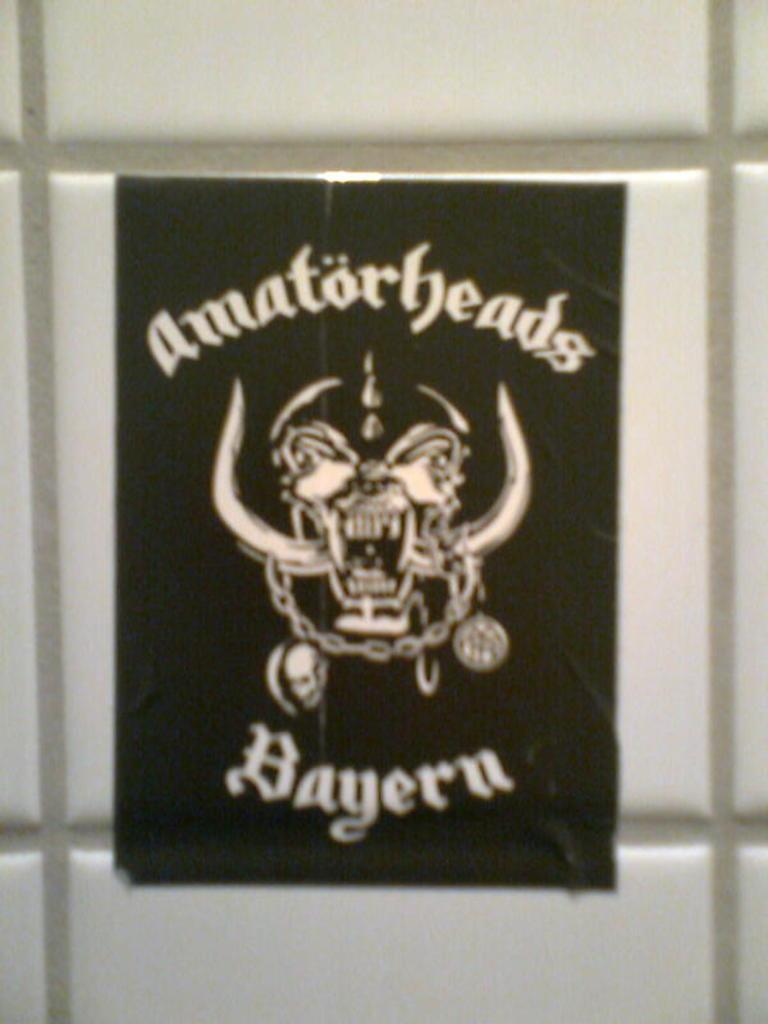What is featured on the poster in the image? The poster has "amator heads" written on it. Where is the poster located in the image? The poster is pasted on a wall. What type of punishment is being depicted on the poster? There is no punishment depicted on the poster; it only has "amator heads" written on it. 